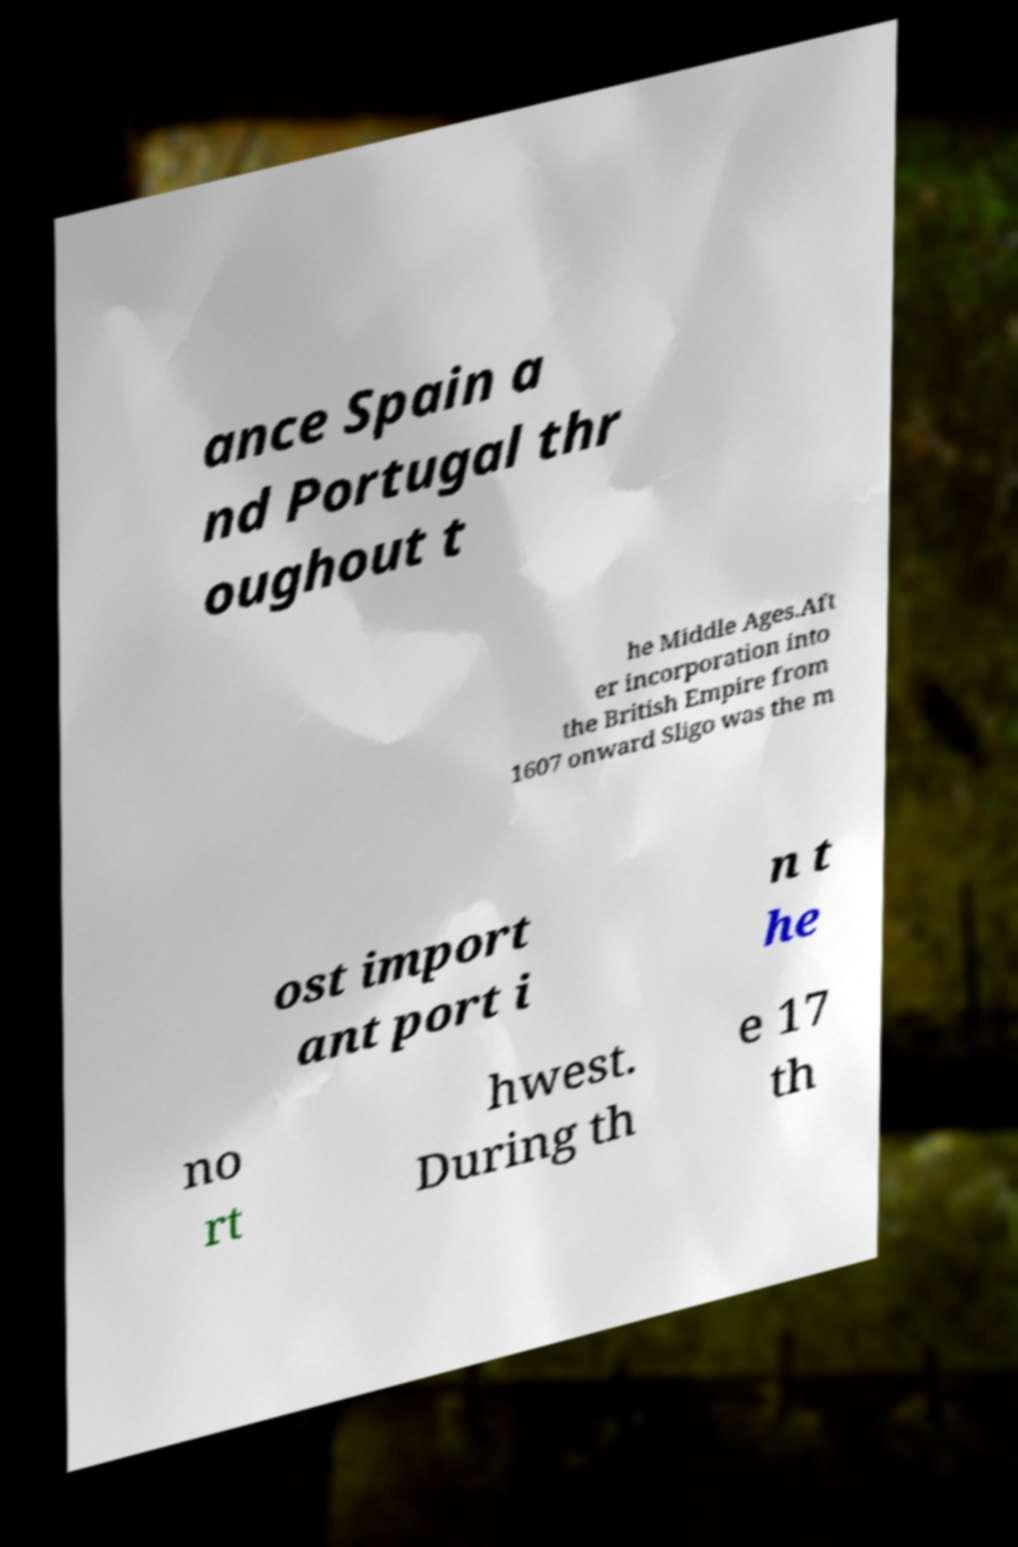Can you read and provide the text displayed in the image?This photo seems to have some interesting text. Can you extract and type it out for me? ance Spain a nd Portugal thr oughout t he Middle Ages.Aft er incorporation into the British Empire from 1607 onward Sligo was the m ost import ant port i n t he no rt hwest. During th e 17 th 